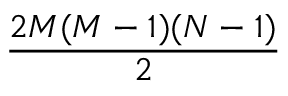Convert formula to latex. <formula><loc_0><loc_0><loc_500><loc_500>\frac { 2 M ( M - 1 ) ( N - 1 ) } { 2 }</formula> 